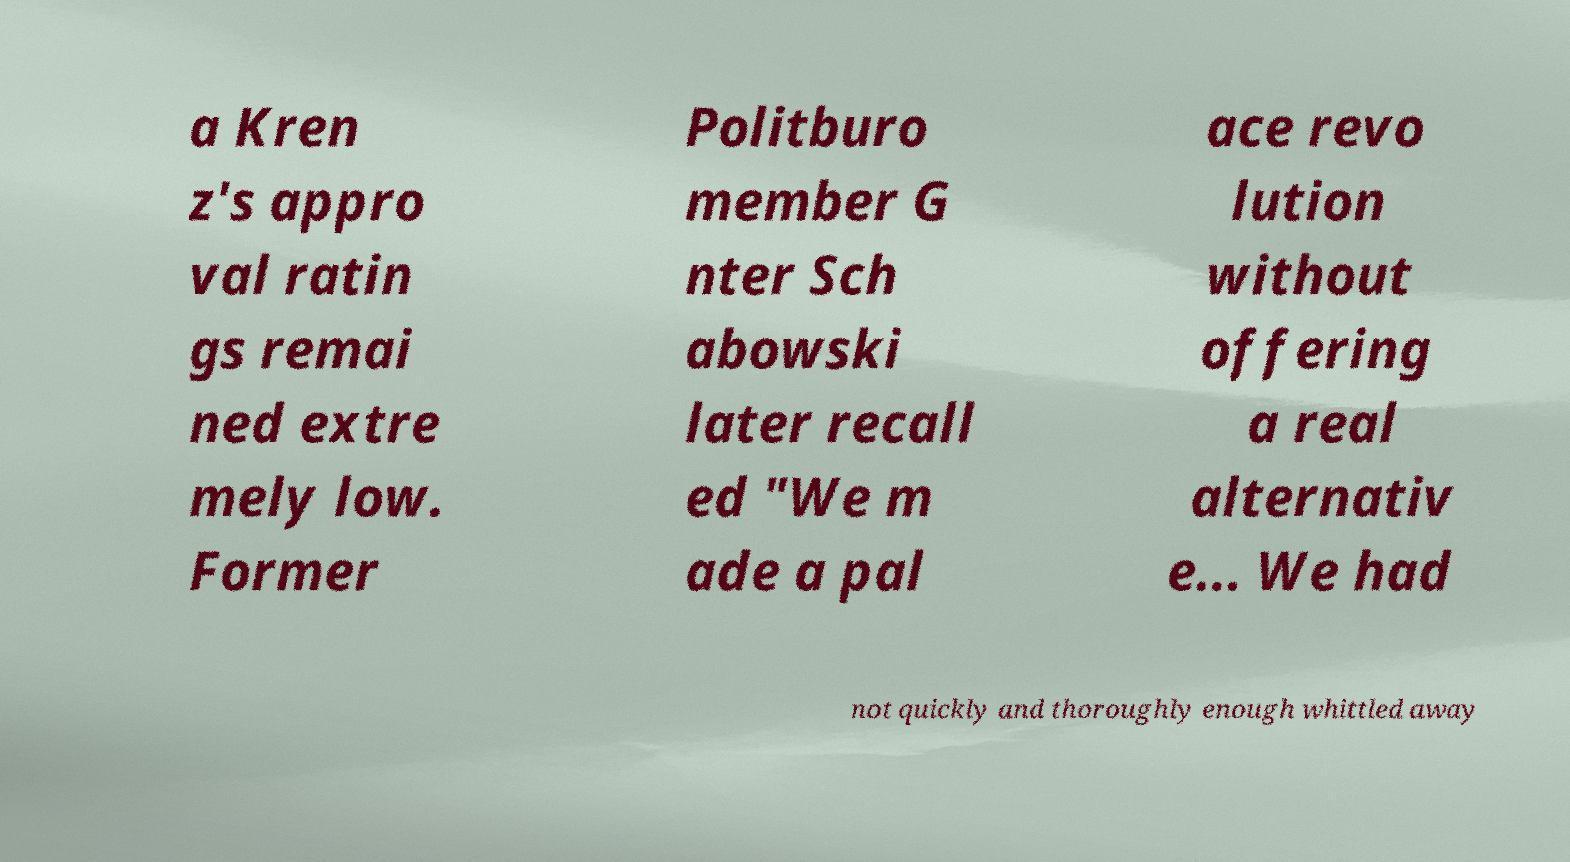Please identify and transcribe the text found in this image. a Kren z's appro val ratin gs remai ned extre mely low. Former Politburo member G nter Sch abowski later recall ed "We m ade a pal ace revo lution without offering a real alternativ e... We had not quickly and thoroughly enough whittled away 